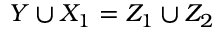Convert formula to latex. <formula><loc_0><loc_0><loc_500><loc_500>Y \cup X _ { 1 } = Z _ { 1 } \cup Z _ { 2 }</formula> 